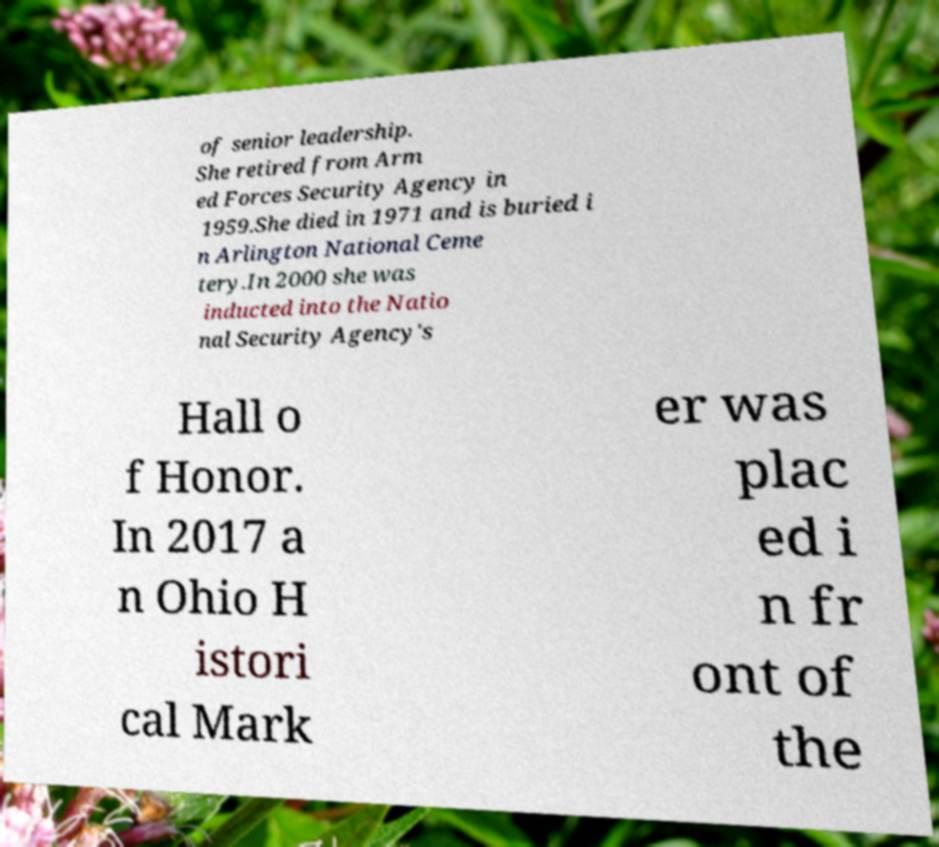What messages or text are displayed in this image? I need them in a readable, typed format. of senior leadership. She retired from Arm ed Forces Security Agency in 1959.She died in 1971 and is buried i n Arlington National Ceme tery.In 2000 she was inducted into the Natio nal Security Agency's Hall o f Honor. In 2017 a n Ohio H istori cal Mark er was plac ed i n fr ont of the 